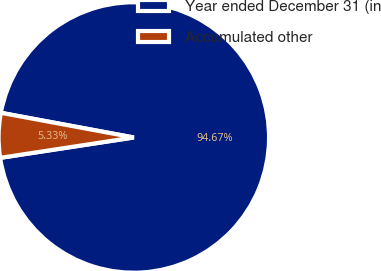Convert chart to OTSL. <chart><loc_0><loc_0><loc_500><loc_500><pie_chart><fcel>Year ended December 31 (in<fcel>Accumulated other<nl><fcel>94.67%<fcel>5.33%<nl></chart> 